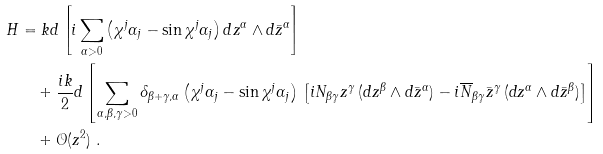Convert formula to latex. <formula><loc_0><loc_0><loc_500><loc_500>H & = k d \left [ i \sum _ { \alpha > 0 } \left ( \chi ^ { j } \alpha _ { j } - \sin { \chi ^ { j } \alpha _ { j } } \right ) d z ^ { \alpha } \wedge d \bar { z } ^ { \alpha } \right ] \\ & \quad + \frac { i k } { 2 } d \left [ \sum _ { \alpha , \beta , \gamma > 0 } \delta _ { \beta + \gamma , \alpha } \left ( \chi ^ { j } \alpha _ { j } - \sin { \chi ^ { j } \alpha _ { j } } \right ) \, \left [ i N _ { \beta \gamma } z ^ { \gamma } \, ( d z ^ { \beta } \wedge d \bar { z } ^ { \alpha } ) - i \overline { N } _ { \beta \gamma } \bar { z } ^ { \gamma } \, ( d z ^ { \alpha } \wedge d \bar { z } ^ { \beta } ) \right ] \right ] \\ & \quad + \mathcal { O } ( z ^ { 2 } ) \ .</formula> 